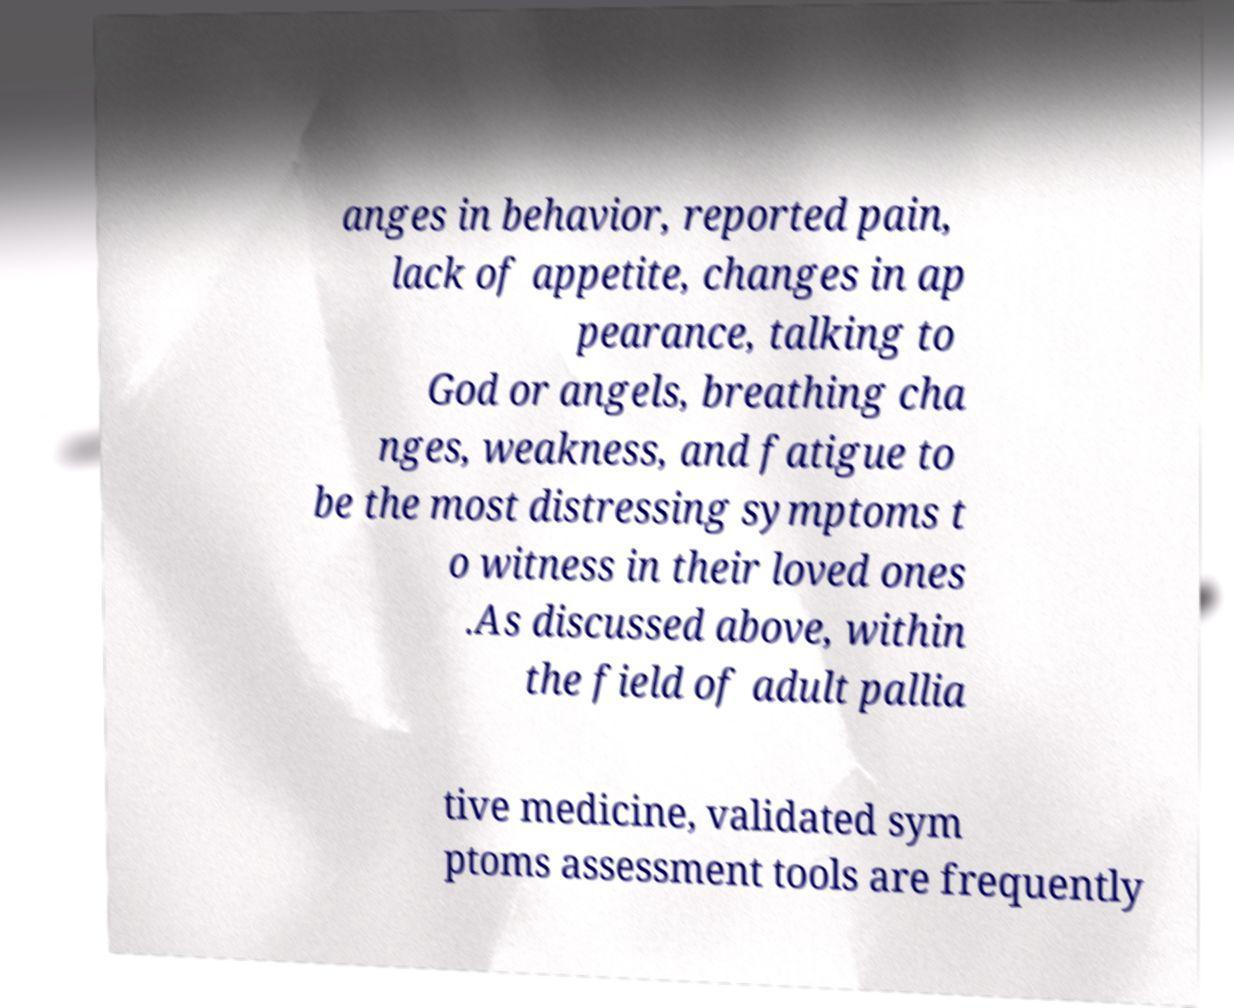Can you read and provide the text displayed in the image?This photo seems to have some interesting text. Can you extract and type it out for me? anges in behavior, reported pain, lack of appetite, changes in ap pearance, talking to God or angels, breathing cha nges, weakness, and fatigue to be the most distressing symptoms t o witness in their loved ones .As discussed above, within the field of adult pallia tive medicine, validated sym ptoms assessment tools are frequently 